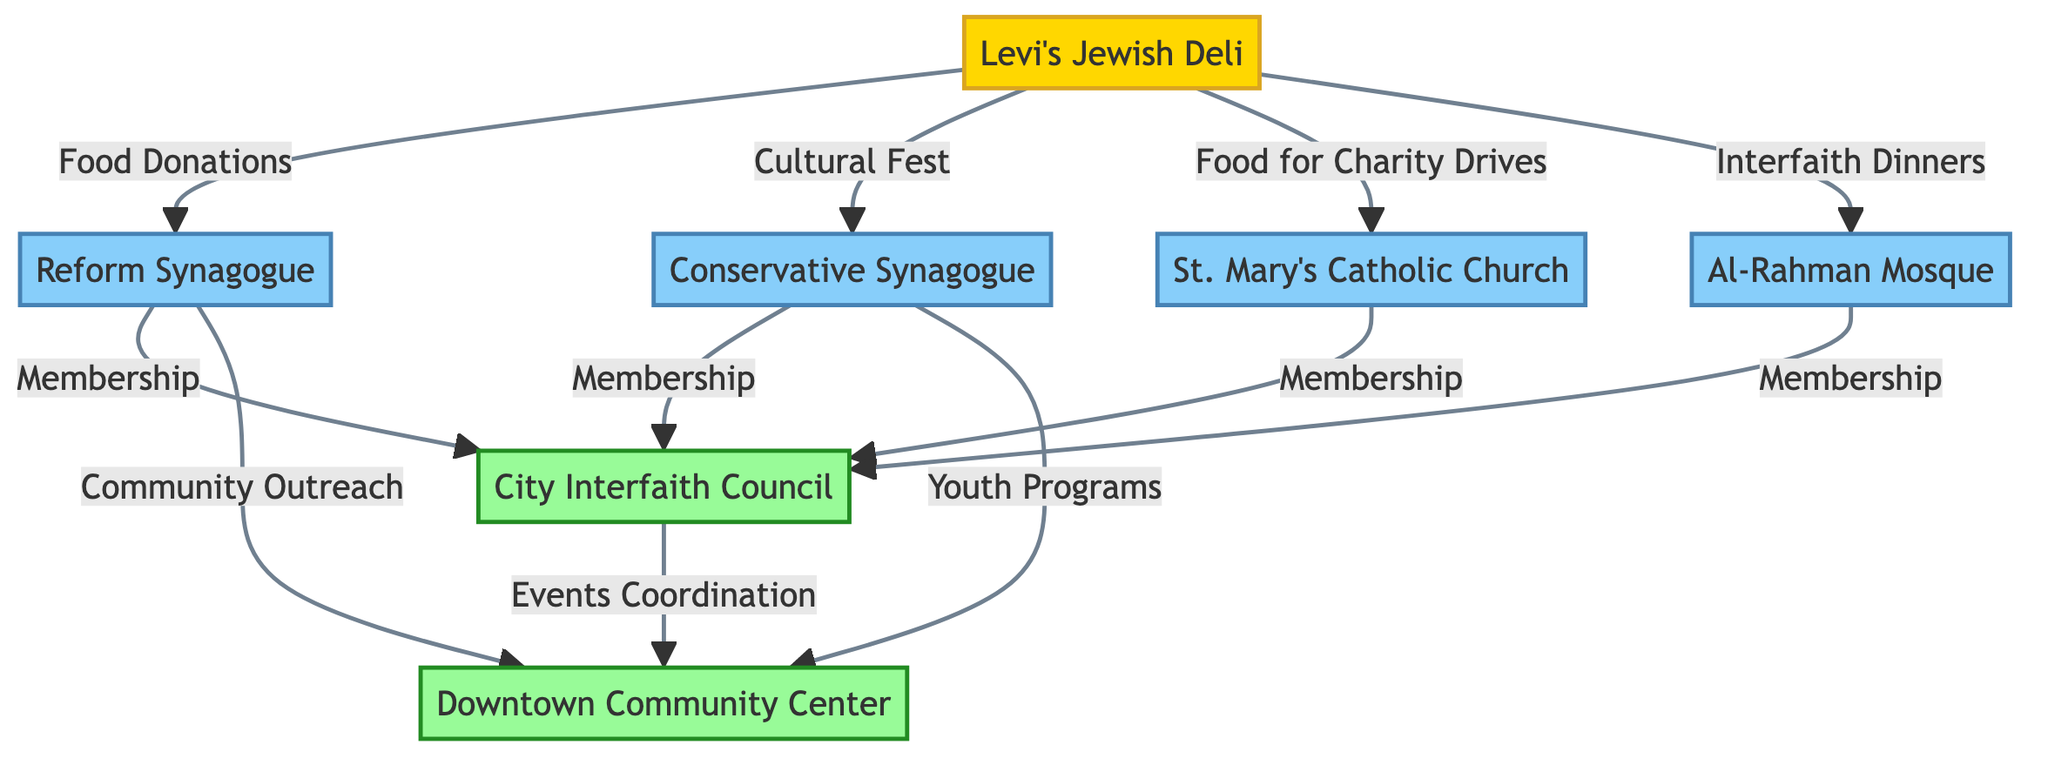What's the total number of organizations represented in the diagram? To determine the total number of organizations, we need to count the individual nodes that are classified as organizations. These are the City Interfaith Council and Downtown Community Center, totaling two organizations.
Answer: 2 Which religious organization is connected to Levi's Jewish Deli through Food Donations? The diagram shows a direct connection labeled "Food Donations" between Levi's Jewish Deli and the Reform Synagogue, indicating that this is the religious organization linked to that specific contribution.
Answer: Reform Synagogue How many religious organizations are connected to the City Interfaith Council? We need to find the religious organizations that have a direct link to the City Interfaith Council. These are Reform Synagogue, Conservative Synagogue, Catholic Church, and Al-Rahman Mosque, which totals four religious organizations connected to it.
Answer: 4 Which event is Levi's Jewish Deli organizing with the Al-Rahman Mosque? According to the diagram, the event organized between Levi's Jewish Deli and Al-Rahman Mosque is titled "Interfaith Dinners." This is the specific collaborative event mentioned in their connection.
Answer: Interfaith Dinners What type of outreach does the Reform Synagogue perform with the Downtown Community Center? The Reform Synagogue is shown in the diagram as conducting "Community Outreach" with the Downtown Community Center, highlighting the type of partnership established between them.
Answer: Community Outreach Which organization coordinates events with the City Interfaith Council? The diagram indicates that the Downtown Community Center is responsible for "Events Coordination" with the City Interfaith Council. This showcases their collaborative role in organizing events.
Answer: Downtown Community Center Which religious organization participates in Youth Programs offered at the Downtown Community Center? The diagram connects the Conservative Synagogue directly to the Downtown Community Center through "Youth Programs," revealing its participation in this specific program.
Answer: Conservative Synagogue What are the three types of contributions Levi's Jewish Deli makes to religious organizations? By examining the diagram, we see that Levi's Jewish Deli contributes through "Food Donations" to Reform Synagogue, "Food for Charity Drives" to Catholic Church, and "Cultural Fest" to Conservative Synagogue. These three contributions categorize its involvement.
Answer: Food Donations, Food for Charity Drives, Cultural Fest How many nodes in the diagram are classified as religious? To identify the total number of religious nodes, we note the nodes labeled as such: Reform Synagogue, Conservative Synagogue, St. Mary's Catholic Church, and Al-Rahman Mosque. This gives a total of four religious nodes in the diagram.
Answer: 4 